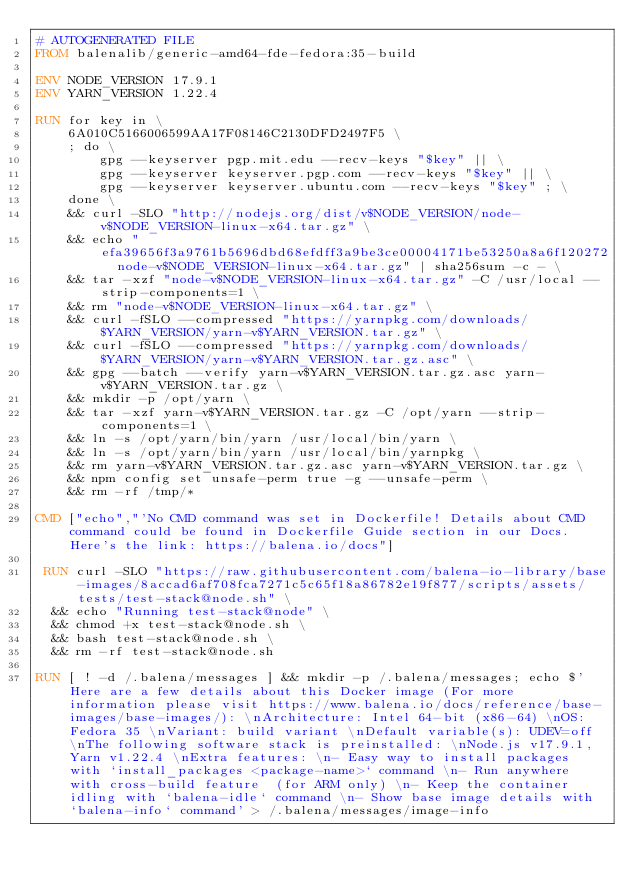<code> <loc_0><loc_0><loc_500><loc_500><_Dockerfile_># AUTOGENERATED FILE
FROM balenalib/generic-amd64-fde-fedora:35-build

ENV NODE_VERSION 17.9.1
ENV YARN_VERSION 1.22.4

RUN for key in \
	6A010C5166006599AA17F08146C2130DFD2497F5 \
	; do \
		gpg --keyserver pgp.mit.edu --recv-keys "$key" || \
		gpg --keyserver keyserver.pgp.com --recv-keys "$key" || \
		gpg --keyserver keyserver.ubuntu.com --recv-keys "$key" ; \
	done \
	&& curl -SLO "http://nodejs.org/dist/v$NODE_VERSION/node-v$NODE_VERSION-linux-x64.tar.gz" \
	&& echo "efa39656f3a9761b5696dbd68efdff3a9be3ce00004171be53250a8a6f120272  node-v$NODE_VERSION-linux-x64.tar.gz" | sha256sum -c - \
	&& tar -xzf "node-v$NODE_VERSION-linux-x64.tar.gz" -C /usr/local --strip-components=1 \
	&& rm "node-v$NODE_VERSION-linux-x64.tar.gz" \
	&& curl -fSLO --compressed "https://yarnpkg.com/downloads/$YARN_VERSION/yarn-v$YARN_VERSION.tar.gz" \
	&& curl -fSLO --compressed "https://yarnpkg.com/downloads/$YARN_VERSION/yarn-v$YARN_VERSION.tar.gz.asc" \
	&& gpg --batch --verify yarn-v$YARN_VERSION.tar.gz.asc yarn-v$YARN_VERSION.tar.gz \
	&& mkdir -p /opt/yarn \
	&& tar -xzf yarn-v$YARN_VERSION.tar.gz -C /opt/yarn --strip-components=1 \
	&& ln -s /opt/yarn/bin/yarn /usr/local/bin/yarn \
	&& ln -s /opt/yarn/bin/yarn /usr/local/bin/yarnpkg \
	&& rm yarn-v$YARN_VERSION.tar.gz.asc yarn-v$YARN_VERSION.tar.gz \
	&& npm config set unsafe-perm true -g --unsafe-perm \
	&& rm -rf /tmp/*

CMD ["echo","'No CMD command was set in Dockerfile! Details about CMD command could be found in Dockerfile Guide section in our Docs. Here's the link: https://balena.io/docs"]

 RUN curl -SLO "https://raw.githubusercontent.com/balena-io-library/base-images/8accad6af708fca7271c5c65f18a86782e19f877/scripts/assets/tests/test-stack@node.sh" \
  && echo "Running test-stack@node" \
  && chmod +x test-stack@node.sh \
  && bash test-stack@node.sh \
  && rm -rf test-stack@node.sh 

RUN [ ! -d /.balena/messages ] && mkdir -p /.balena/messages; echo $'Here are a few details about this Docker image (For more information please visit https://www.balena.io/docs/reference/base-images/base-images/): \nArchitecture: Intel 64-bit (x86-64) \nOS: Fedora 35 \nVariant: build variant \nDefault variable(s): UDEV=off \nThe following software stack is preinstalled: \nNode.js v17.9.1, Yarn v1.22.4 \nExtra features: \n- Easy way to install packages with `install_packages <package-name>` command \n- Run anywhere with cross-build feature  (for ARM only) \n- Keep the container idling with `balena-idle` command \n- Show base image details with `balena-info` command' > /.balena/messages/image-info</code> 